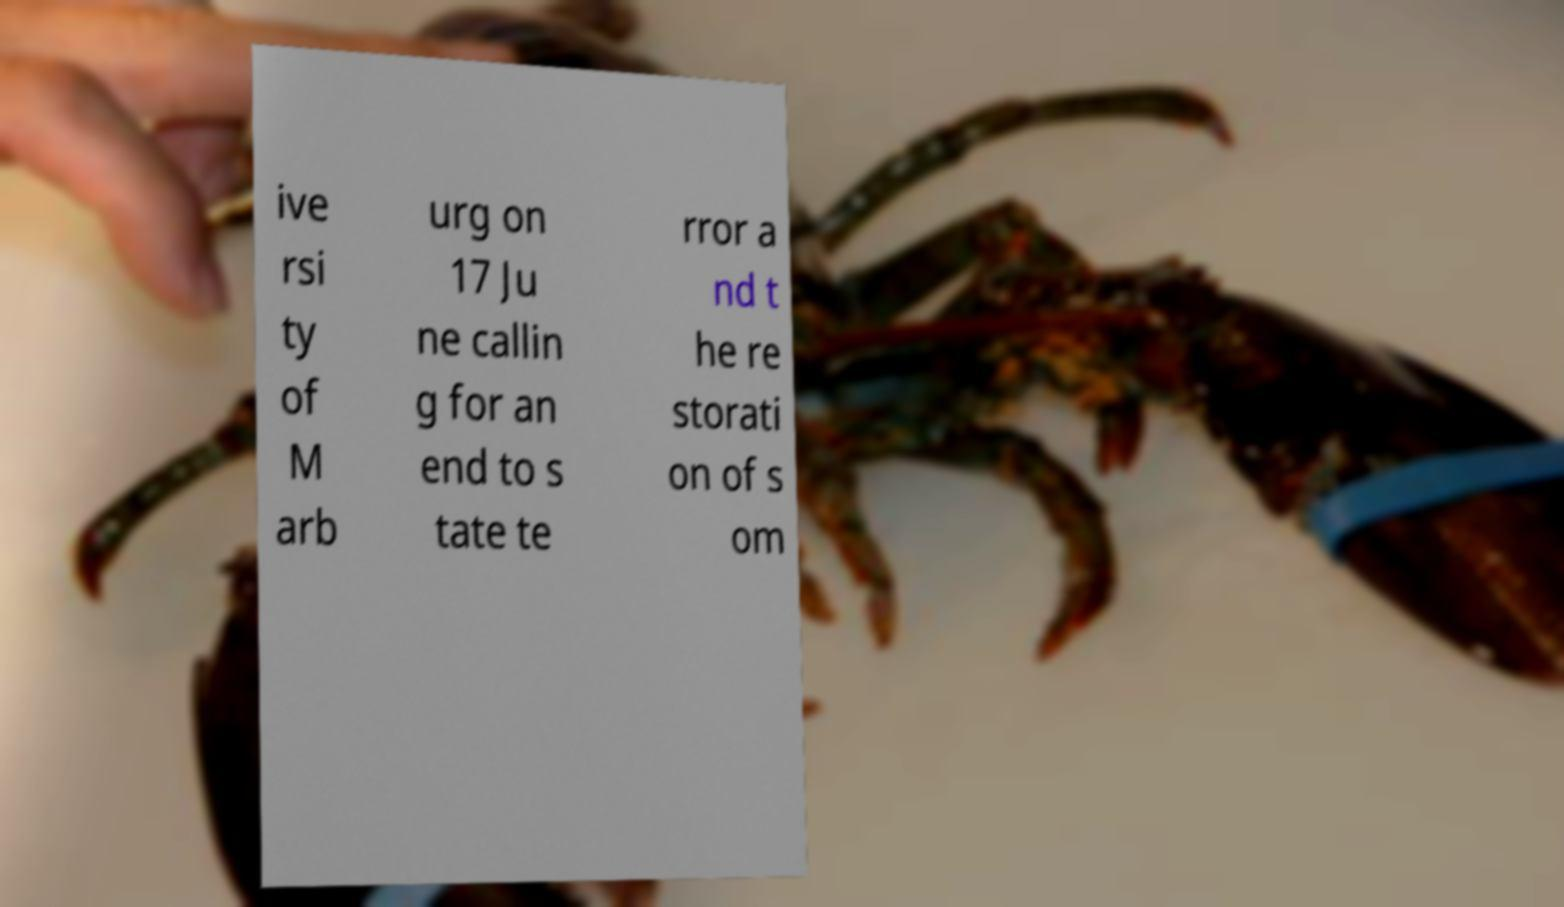Could you extract and type out the text from this image? ive rsi ty of M arb urg on 17 Ju ne callin g for an end to s tate te rror a nd t he re storati on of s om 